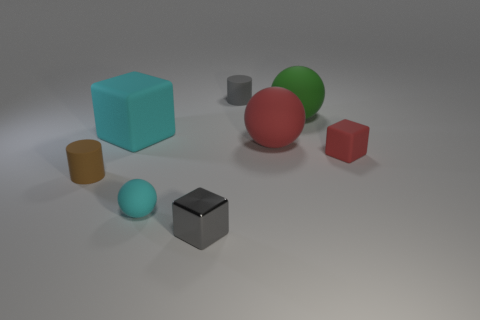What size is the cube that is behind the red matte object that is behind the small matte block?
Ensure brevity in your answer.  Large. What number of objects are tiny red rubber blocks that are behind the brown object or small brown things?
Provide a short and direct response. 2. Are there any rubber cylinders of the same size as the gray metallic object?
Make the answer very short. Yes. Are there any blocks that are right of the cube left of the small metallic block?
Your answer should be very brief. Yes. What number of balls are either blue rubber objects or small cyan objects?
Your answer should be compact. 1. Are there any big red objects of the same shape as the brown rubber thing?
Make the answer very short. No. What is the shape of the gray matte thing?
Your response must be concise. Cylinder. What number of things are either large brown matte cylinders or matte things?
Keep it short and to the point. 7. Does the rubber cylinder that is in front of the small red object have the same size as the rubber ball that is in front of the small brown object?
Ensure brevity in your answer.  Yes. What number of other objects are the same material as the large red thing?
Give a very brief answer. 6. 